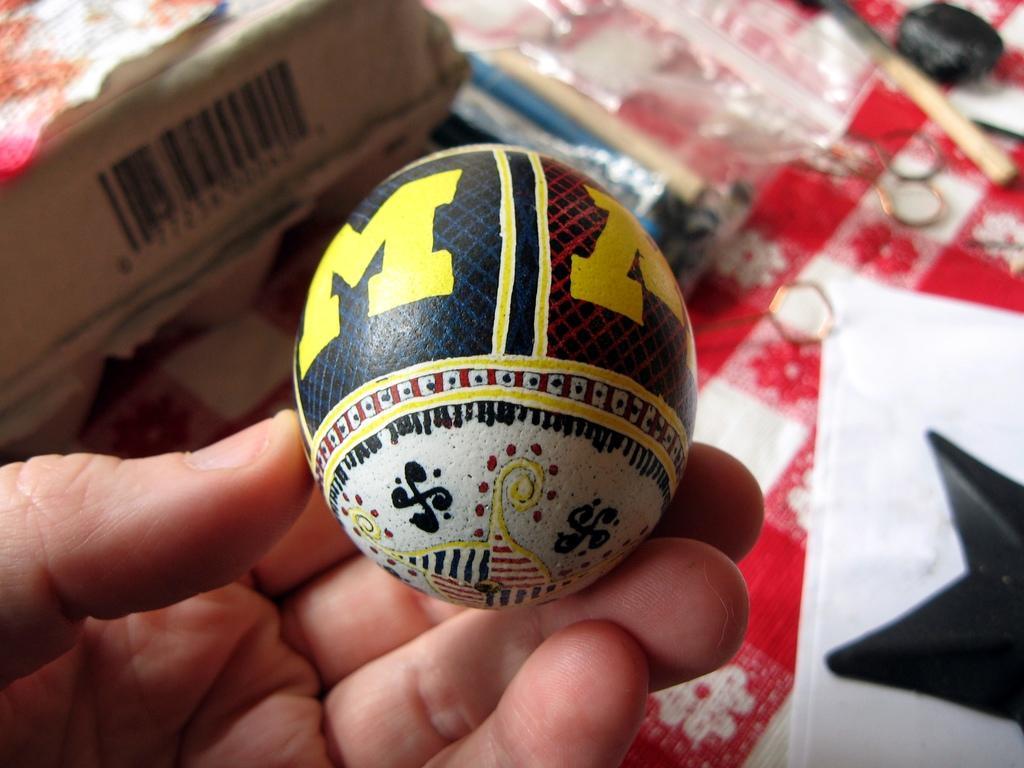Can you describe this image briefly? In this image we can see a person's hand and he is holding a ball and there are few objects. 